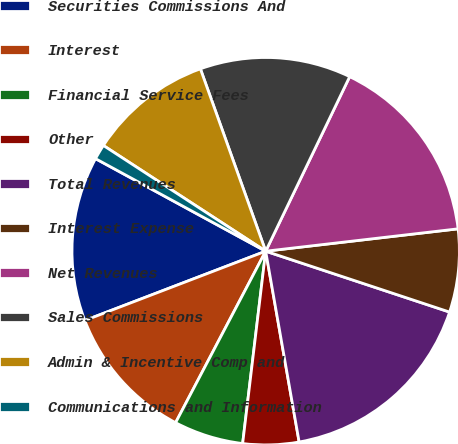Convert chart to OTSL. <chart><loc_0><loc_0><loc_500><loc_500><pie_chart><fcel>Securities Commissions And<fcel>Interest<fcel>Financial Service Fees<fcel>Other<fcel>Total Revenues<fcel>Interest Expense<fcel>Net Revenues<fcel>Sales Commissions<fcel>Admin & Incentive Comp and<fcel>Communications and Information<nl><fcel>13.75%<fcel>11.48%<fcel>5.8%<fcel>4.66%<fcel>17.15%<fcel>6.93%<fcel>16.02%<fcel>12.61%<fcel>10.34%<fcel>1.26%<nl></chart> 